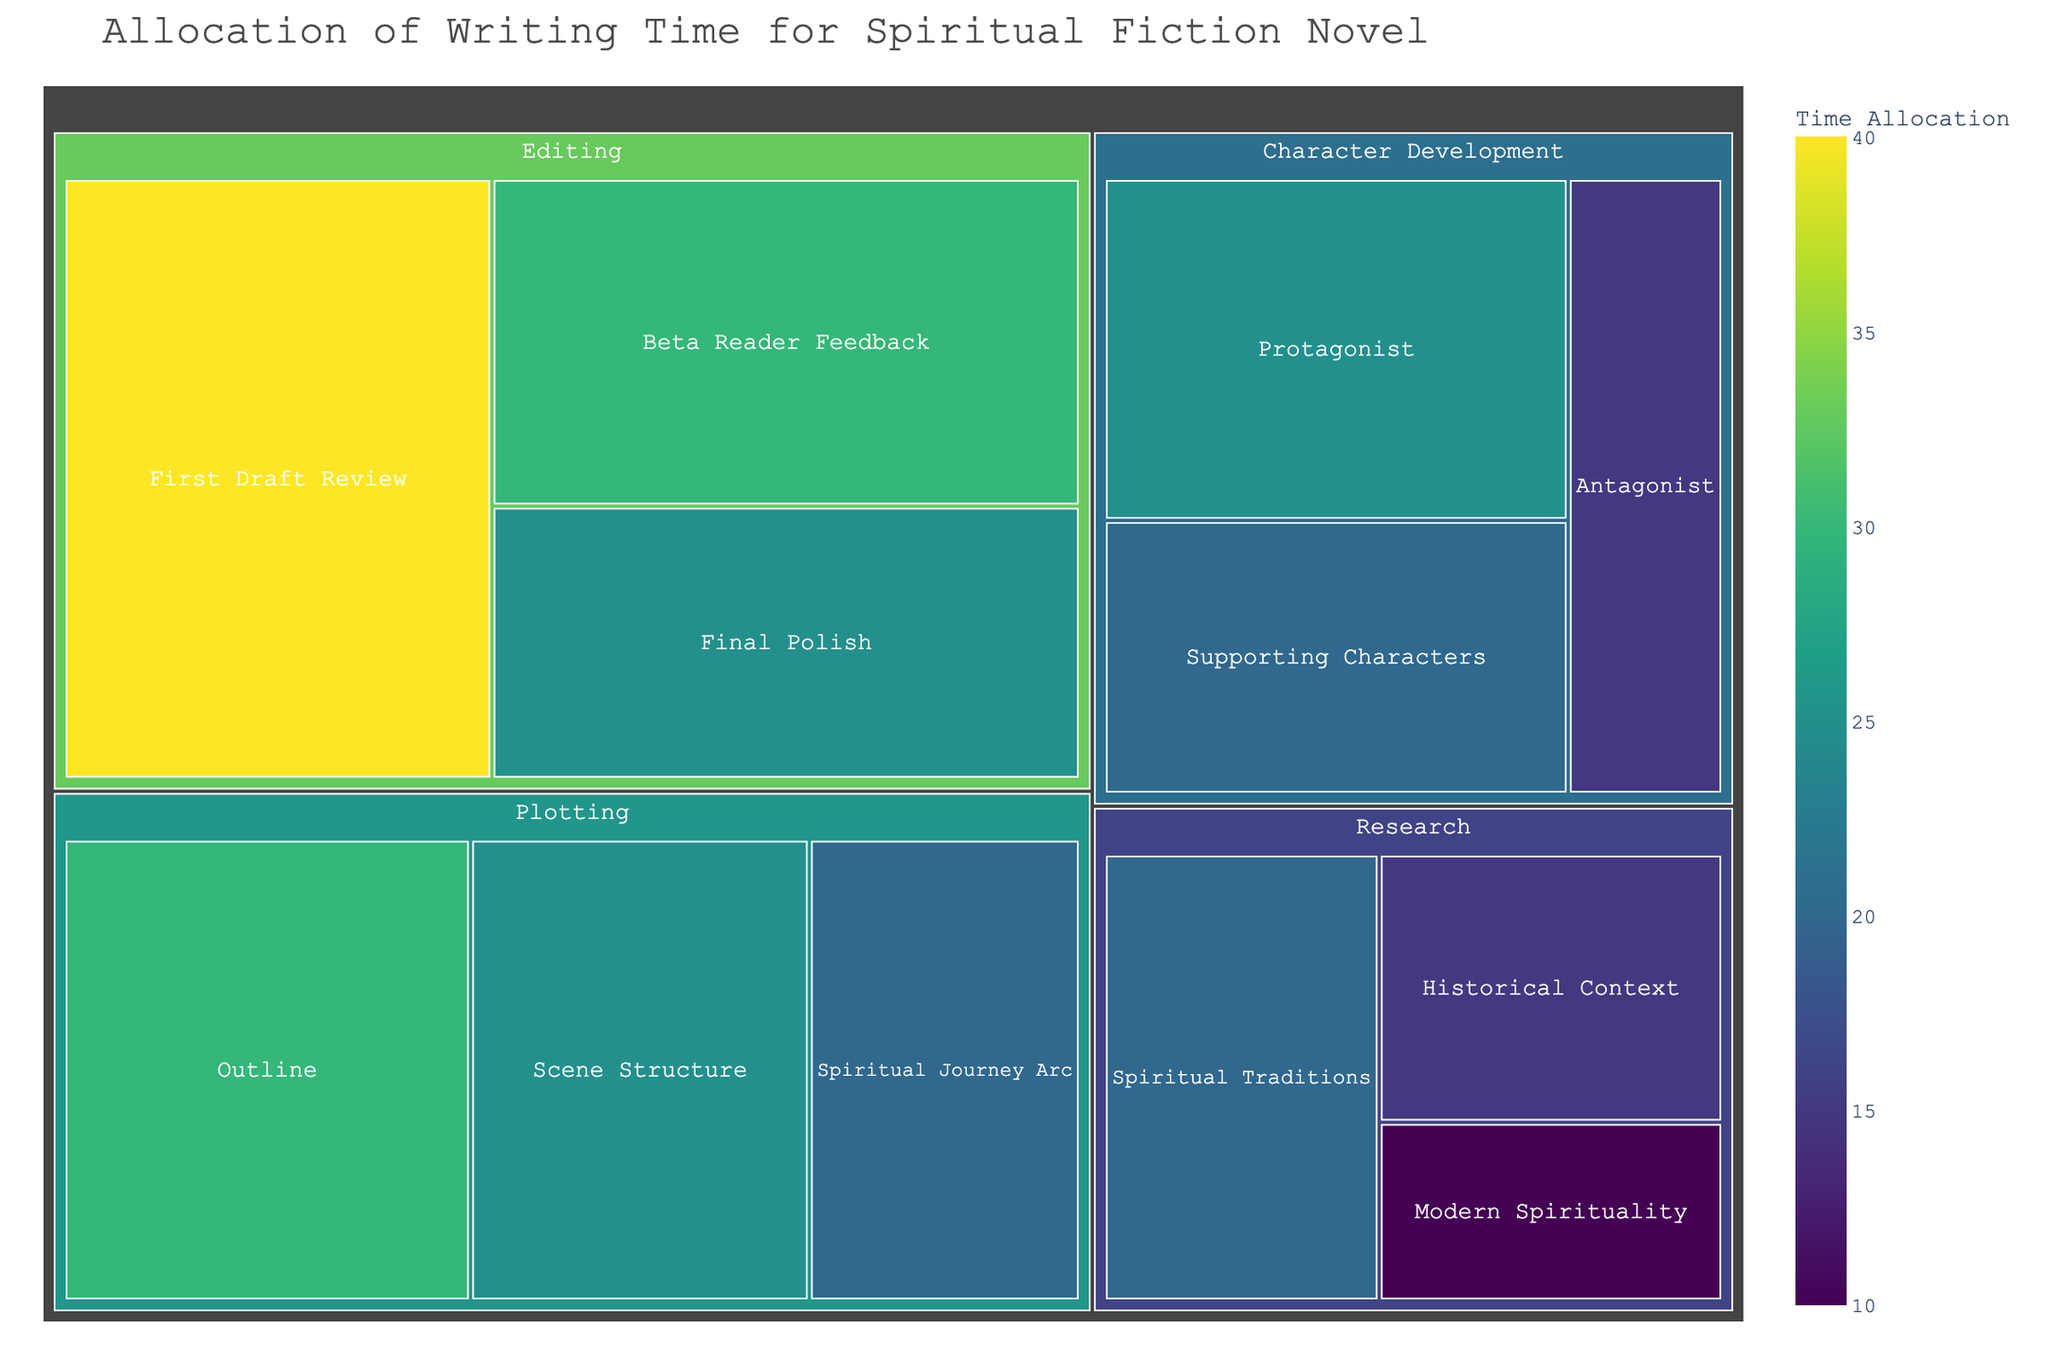What's the largest time allocation category? From the figure, the largest section represents Editing. Within this category, the total time allocation accounts for a significant part of the plot.
Answer: Editing What's the specific time allocation for First Draft Review in Editing? By inspecting the larger sub-blocks within Editing, it is evident that First Draft Review is allocated 40 units.
Answer: 40 How much total time is allocated to Research? Summing up the values for Spiritual Traditions (20), Historical Context (15), and Modern Spirituality (10), the total time allocation for Research is 45 units.
Answer: 45 Which subcategory has the smallest time allocation? By finding the smallest block in the treemap across all categories, Modern Spirituality in Research is the smallest with 10 units.
Answer: Modern Spirituality What is the combined time allocation for Character Development and Plotting? Summing up all subcategories within Character Development (Protagonist: 25, Supporting Characters: 20, Antagonist: 15) and Plotting (Outline: 30, Scene Structure: 25, Spiritual Journey Arc: 20) obtains 135 units.
Answer: 135 How does the time allocation for Scene Structure compare to Final Polish? Scene Structure in Plotting is allocated 25 units, the same as Final Polish in Editing.
Answer: Equal What is the range of time allocation values seen in the treemap? The smallest value is 10 (Modern Spirituality), and the largest is 40 (First Draft Review), giving a range of 40-10 = 30.
Answer: 30 Which subcategory in Character Development is allocated the least amount of time? Within Character Development, the block for Antagonist is the smallest at 15 units.
Answer: Antagonist What percentage of plotting time is devoted to the Spiritual Journey Arc? Total plotting time is the sum of Outline (30), Scene Structure (25), and Spiritual Journey Arc (20), which equals 75 units. The percentage for Spiritual Journey Arc is (20/75) * 100% = 26.67%.
Answer: 26.67% What is the difference in time allocation between the largest and smallest subcategories in any category? The largest subcategory is First Draft Review (40 units) and the smallest is Modern Spirituality (10 units). The difference is 40 - 10 = 30 units.
Answer: 30 